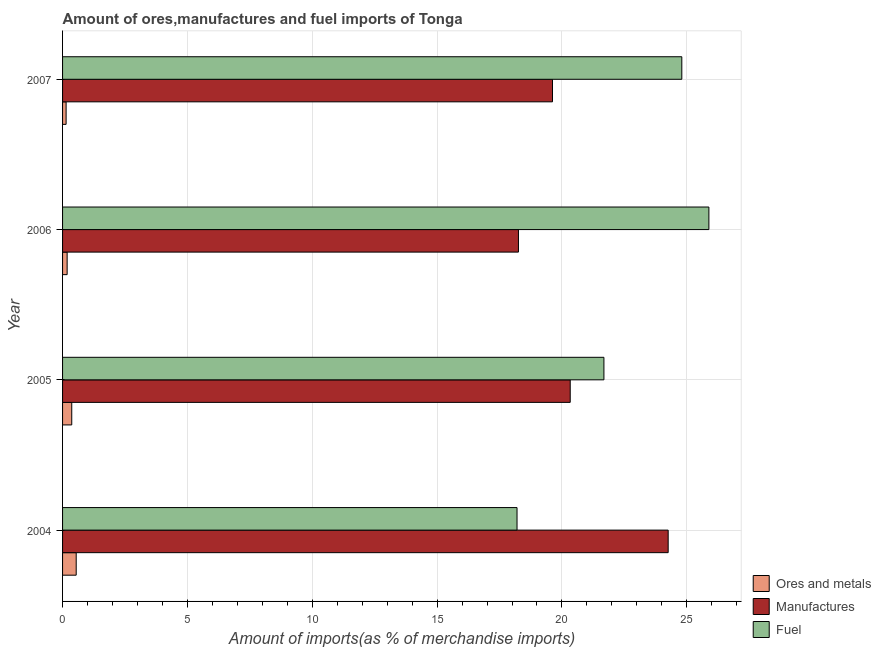How many different coloured bars are there?
Your answer should be compact. 3. Are the number of bars on each tick of the Y-axis equal?
Provide a short and direct response. Yes. What is the label of the 2nd group of bars from the top?
Make the answer very short. 2006. What is the percentage of manufactures imports in 2005?
Offer a terse response. 20.33. Across all years, what is the maximum percentage of manufactures imports?
Keep it short and to the point. 24.25. Across all years, what is the minimum percentage of ores and metals imports?
Make the answer very short. 0.14. In which year was the percentage of manufactures imports minimum?
Offer a very short reply. 2006. What is the total percentage of ores and metals imports in the graph?
Ensure brevity in your answer.  1.24. What is the difference between the percentage of manufactures imports in 2004 and that in 2005?
Give a very brief answer. 3.92. What is the difference between the percentage of manufactures imports in 2006 and the percentage of ores and metals imports in 2007?
Offer a terse response. 18.12. What is the average percentage of ores and metals imports per year?
Ensure brevity in your answer.  0.31. In the year 2006, what is the difference between the percentage of manufactures imports and percentage of ores and metals imports?
Provide a succinct answer. 18.07. In how many years, is the percentage of fuel imports greater than 19 %?
Make the answer very short. 3. What is the ratio of the percentage of manufactures imports in 2004 to that in 2007?
Ensure brevity in your answer.  1.24. What is the difference between the highest and the second highest percentage of manufactures imports?
Give a very brief answer. 3.92. What is the difference between the highest and the lowest percentage of ores and metals imports?
Give a very brief answer. 0.4. What does the 1st bar from the top in 2007 represents?
Your answer should be very brief. Fuel. What does the 3rd bar from the bottom in 2004 represents?
Make the answer very short. Fuel. Is it the case that in every year, the sum of the percentage of ores and metals imports and percentage of manufactures imports is greater than the percentage of fuel imports?
Provide a short and direct response. No. How many bars are there?
Make the answer very short. 12. Are all the bars in the graph horizontal?
Provide a succinct answer. Yes. Does the graph contain any zero values?
Offer a terse response. No. Does the graph contain grids?
Give a very brief answer. Yes. Where does the legend appear in the graph?
Offer a terse response. Bottom right. How are the legend labels stacked?
Your response must be concise. Vertical. What is the title of the graph?
Keep it short and to the point. Amount of ores,manufactures and fuel imports of Tonga. Does "Industry" appear as one of the legend labels in the graph?
Your response must be concise. No. What is the label or title of the X-axis?
Give a very brief answer. Amount of imports(as % of merchandise imports). What is the label or title of the Y-axis?
Provide a succinct answer. Year. What is the Amount of imports(as % of merchandise imports) in Ores and metals in 2004?
Your answer should be compact. 0.55. What is the Amount of imports(as % of merchandise imports) in Manufactures in 2004?
Your answer should be compact. 24.25. What is the Amount of imports(as % of merchandise imports) in Fuel in 2004?
Make the answer very short. 18.2. What is the Amount of imports(as % of merchandise imports) in Ores and metals in 2005?
Your response must be concise. 0.37. What is the Amount of imports(as % of merchandise imports) in Manufactures in 2005?
Keep it short and to the point. 20.33. What is the Amount of imports(as % of merchandise imports) of Fuel in 2005?
Provide a short and direct response. 21.68. What is the Amount of imports(as % of merchandise imports) in Ores and metals in 2006?
Ensure brevity in your answer.  0.18. What is the Amount of imports(as % of merchandise imports) in Manufactures in 2006?
Provide a short and direct response. 18.26. What is the Amount of imports(as % of merchandise imports) of Fuel in 2006?
Your answer should be compact. 25.88. What is the Amount of imports(as % of merchandise imports) of Ores and metals in 2007?
Provide a succinct answer. 0.14. What is the Amount of imports(as % of merchandise imports) of Manufactures in 2007?
Provide a short and direct response. 19.62. What is the Amount of imports(as % of merchandise imports) of Fuel in 2007?
Offer a terse response. 24.8. Across all years, what is the maximum Amount of imports(as % of merchandise imports) of Ores and metals?
Your answer should be compact. 0.55. Across all years, what is the maximum Amount of imports(as % of merchandise imports) in Manufactures?
Ensure brevity in your answer.  24.25. Across all years, what is the maximum Amount of imports(as % of merchandise imports) of Fuel?
Offer a terse response. 25.88. Across all years, what is the minimum Amount of imports(as % of merchandise imports) of Ores and metals?
Offer a very short reply. 0.14. Across all years, what is the minimum Amount of imports(as % of merchandise imports) in Manufactures?
Give a very brief answer. 18.26. Across all years, what is the minimum Amount of imports(as % of merchandise imports) in Fuel?
Provide a short and direct response. 18.2. What is the total Amount of imports(as % of merchandise imports) in Ores and metals in the graph?
Make the answer very short. 1.24. What is the total Amount of imports(as % of merchandise imports) in Manufactures in the graph?
Your answer should be very brief. 82.46. What is the total Amount of imports(as % of merchandise imports) of Fuel in the graph?
Make the answer very short. 90.56. What is the difference between the Amount of imports(as % of merchandise imports) in Ores and metals in 2004 and that in 2005?
Make the answer very short. 0.18. What is the difference between the Amount of imports(as % of merchandise imports) in Manufactures in 2004 and that in 2005?
Your answer should be compact. 3.92. What is the difference between the Amount of imports(as % of merchandise imports) in Fuel in 2004 and that in 2005?
Ensure brevity in your answer.  -3.48. What is the difference between the Amount of imports(as % of merchandise imports) in Ores and metals in 2004 and that in 2006?
Make the answer very short. 0.36. What is the difference between the Amount of imports(as % of merchandise imports) in Manufactures in 2004 and that in 2006?
Give a very brief answer. 6. What is the difference between the Amount of imports(as % of merchandise imports) in Fuel in 2004 and that in 2006?
Provide a short and direct response. -7.68. What is the difference between the Amount of imports(as % of merchandise imports) in Ores and metals in 2004 and that in 2007?
Offer a very short reply. 0.4. What is the difference between the Amount of imports(as % of merchandise imports) in Manufactures in 2004 and that in 2007?
Your response must be concise. 4.63. What is the difference between the Amount of imports(as % of merchandise imports) of Fuel in 2004 and that in 2007?
Provide a succinct answer. -6.6. What is the difference between the Amount of imports(as % of merchandise imports) in Ores and metals in 2005 and that in 2006?
Keep it short and to the point. 0.18. What is the difference between the Amount of imports(as % of merchandise imports) in Manufactures in 2005 and that in 2006?
Your response must be concise. 2.07. What is the difference between the Amount of imports(as % of merchandise imports) in Fuel in 2005 and that in 2006?
Offer a terse response. -4.2. What is the difference between the Amount of imports(as % of merchandise imports) in Ores and metals in 2005 and that in 2007?
Your answer should be compact. 0.23. What is the difference between the Amount of imports(as % of merchandise imports) of Manufactures in 2005 and that in 2007?
Offer a terse response. 0.71. What is the difference between the Amount of imports(as % of merchandise imports) in Fuel in 2005 and that in 2007?
Keep it short and to the point. -3.12. What is the difference between the Amount of imports(as % of merchandise imports) of Ores and metals in 2006 and that in 2007?
Offer a terse response. 0.04. What is the difference between the Amount of imports(as % of merchandise imports) of Manufactures in 2006 and that in 2007?
Make the answer very short. -1.36. What is the difference between the Amount of imports(as % of merchandise imports) of Fuel in 2006 and that in 2007?
Offer a very short reply. 1.08. What is the difference between the Amount of imports(as % of merchandise imports) of Ores and metals in 2004 and the Amount of imports(as % of merchandise imports) of Manufactures in 2005?
Give a very brief answer. -19.78. What is the difference between the Amount of imports(as % of merchandise imports) of Ores and metals in 2004 and the Amount of imports(as % of merchandise imports) of Fuel in 2005?
Offer a terse response. -21.13. What is the difference between the Amount of imports(as % of merchandise imports) of Manufactures in 2004 and the Amount of imports(as % of merchandise imports) of Fuel in 2005?
Keep it short and to the point. 2.57. What is the difference between the Amount of imports(as % of merchandise imports) of Ores and metals in 2004 and the Amount of imports(as % of merchandise imports) of Manufactures in 2006?
Offer a very short reply. -17.71. What is the difference between the Amount of imports(as % of merchandise imports) of Ores and metals in 2004 and the Amount of imports(as % of merchandise imports) of Fuel in 2006?
Offer a very short reply. -25.34. What is the difference between the Amount of imports(as % of merchandise imports) in Manufactures in 2004 and the Amount of imports(as % of merchandise imports) in Fuel in 2006?
Offer a terse response. -1.63. What is the difference between the Amount of imports(as % of merchandise imports) of Ores and metals in 2004 and the Amount of imports(as % of merchandise imports) of Manufactures in 2007?
Your answer should be very brief. -19.08. What is the difference between the Amount of imports(as % of merchandise imports) of Ores and metals in 2004 and the Amount of imports(as % of merchandise imports) of Fuel in 2007?
Give a very brief answer. -24.25. What is the difference between the Amount of imports(as % of merchandise imports) in Manufactures in 2004 and the Amount of imports(as % of merchandise imports) in Fuel in 2007?
Your answer should be compact. -0.55. What is the difference between the Amount of imports(as % of merchandise imports) in Ores and metals in 2005 and the Amount of imports(as % of merchandise imports) in Manufactures in 2006?
Your response must be concise. -17.89. What is the difference between the Amount of imports(as % of merchandise imports) of Ores and metals in 2005 and the Amount of imports(as % of merchandise imports) of Fuel in 2006?
Your answer should be very brief. -25.52. What is the difference between the Amount of imports(as % of merchandise imports) of Manufactures in 2005 and the Amount of imports(as % of merchandise imports) of Fuel in 2006?
Provide a short and direct response. -5.55. What is the difference between the Amount of imports(as % of merchandise imports) of Ores and metals in 2005 and the Amount of imports(as % of merchandise imports) of Manufactures in 2007?
Your answer should be compact. -19.25. What is the difference between the Amount of imports(as % of merchandise imports) in Ores and metals in 2005 and the Amount of imports(as % of merchandise imports) in Fuel in 2007?
Your answer should be compact. -24.43. What is the difference between the Amount of imports(as % of merchandise imports) of Manufactures in 2005 and the Amount of imports(as % of merchandise imports) of Fuel in 2007?
Make the answer very short. -4.47. What is the difference between the Amount of imports(as % of merchandise imports) in Ores and metals in 2006 and the Amount of imports(as % of merchandise imports) in Manufactures in 2007?
Give a very brief answer. -19.44. What is the difference between the Amount of imports(as % of merchandise imports) in Ores and metals in 2006 and the Amount of imports(as % of merchandise imports) in Fuel in 2007?
Offer a terse response. -24.62. What is the difference between the Amount of imports(as % of merchandise imports) in Manufactures in 2006 and the Amount of imports(as % of merchandise imports) in Fuel in 2007?
Ensure brevity in your answer.  -6.54. What is the average Amount of imports(as % of merchandise imports) of Ores and metals per year?
Keep it short and to the point. 0.31. What is the average Amount of imports(as % of merchandise imports) of Manufactures per year?
Keep it short and to the point. 20.62. What is the average Amount of imports(as % of merchandise imports) of Fuel per year?
Offer a very short reply. 22.64. In the year 2004, what is the difference between the Amount of imports(as % of merchandise imports) of Ores and metals and Amount of imports(as % of merchandise imports) of Manufactures?
Ensure brevity in your answer.  -23.71. In the year 2004, what is the difference between the Amount of imports(as % of merchandise imports) of Ores and metals and Amount of imports(as % of merchandise imports) of Fuel?
Give a very brief answer. -17.65. In the year 2004, what is the difference between the Amount of imports(as % of merchandise imports) of Manufactures and Amount of imports(as % of merchandise imports) of Fuel?
Keep it short and to the point. 6.05. In the year 2005, what is the difference between the Amount of imports(as % of merchandise imports) in Ores and metals and Amount of imports(as % of merchandise imports) in Manufactures?
Provide a short and direct response. -19.96. In the year 2005, what is the difference between the Amount of imports(as % of merchandise imports) of Ores and metals and Amount of imports(as % of merchandise imports) of Fuel?
Your answer should be compact. -21.31. In the year 2005, what is the difference between the Amount of imports(as % of merchandise imports) in Manufactures and Amount of imports(as % of merchandise imports) in Fuel?
Ensure brevity in your answer.  -1.35. In the year 2006, what is the difference between the Amount of imports(as % of merchandise imports) in Ores and metals and Amount of imports(as % of merchandise imports) in Manufactures?
Provide a short and direct response. -18.07. In the year 2006, what is the difference between the Amount of imports(as % of merchandise imports) in Ores and metals and Amount of imports(as % of merchandise imports) in Fuel?
Offer a terse response. -25.7. In the year 2006, what is the difference between the Amount of imports(as % of merchandise imports) in Manufactures and Amount of imports(as % of merchandise imports) in Fuel?
Ensure brevity in your answer.  -7.63. In the year 2007, what is the difference between the Amount of imports(as % of merchandise imports) in Ores and metals and Amount of imports(as % of merchandise imports) in Manufactures?
Your answer should be very brief. -19.48. In the year 2007, what is the difference between the Amount of imports(as % of merchandise imports) of Ores and metals and Amount of imports(as % of merchandise imports) of Fuel?
Offer a very short reply. -24.66. In the year 2007, what is the difference between the Amount of imports(as % of merchandise imports) of Manufactures and Amount of imports(as % of merchandise imports) of Fuel?
Offer a terse response. -5.18. What is the ratio of the Amount of imports(as % of merchandise imports) of Ores and metals in 2004 to that in 2005?
Make the answer very short. 1.48. What is the ratio of the Amount of imports(as % of merchandise imports) of Manufactures in 2004 to that in 2005?
Give a very brief answer. 1.19. What is the ratio of the Amount of imports(as % of merchandise imports) in Fuel in 2004 to that in 2005?
Your response must be concise. 0.84. What is the ratio of the Amount of imports(as % of merchandise imports) of Ores and metals in 2004 to that in 2006?
Your answer should be compact. 2.98. What is the ratio of the Amount of imports(as % of merchandise imports) of Manufactures in 2004 to that in 2006?
Your response must be concise. 1.33. What is the ratio of the Amount of imports(as % of merchandise imports) of Fuel in 2004 to that in 2006?
Offer a very short reply. 0.7. What is the ratio of the Amount of imports(as % of merchandise imports) in Ores and metals in 2004 to that in 2007?
Your response must be concise. 3.85. What is the ratio of the Amount of imports(as % of merchandise imports) in Manufactures in 2004 to that in 2007?
Provide a succinct answer. 1.24. What is the ratio of the Amount of imports(as % of merchandise imports) in Fuel in 2004 to that in 2007?
Ensure brevity in your answer.  0.73. What is the ratio of the Amount of imports(as % of merchandise imports) in Ores and metals in 2005 to that in 2006?
Offer a very short reply. 2.01. What is the ratio of the Amount of imports(as % of merchandise imports) in Manufactures in 2005 to that in 2006?
Offer a terse response. 1.11. What is the ratio of the Amount of imports(as % of merchandise imports) in Fuel in 2005 to that in 2006?
Make the answer very short. 0.84. What is the ratio of the Amount of imports(as % of merchandise imports) in Ores and metals in 2005 to that in 2007?
Keep it short and to the point. 2.59. What is the ratio of the Amount of imports(as % of merchandise imports) of Manufactures in 2005 to that in 2007?
Offer a terse response. 1.04. What is the ratio of the Amount of imports(as % of merchandise imports) of Fuel in 2005 to that in 2007?
Make the answer very short. 0.87. What is the ratio of the Amount of imports(as % of merchandise imports) in Ores and metals in 2006 to that in 2007?
Make the answer very short. 1.29. What is the ratio of the Amount of imports(as % of merchandise imports) of Manufactures in 2006 to that in 2007?
Make the answer very short. 0.93. What is the ratio of the Amount of imports(as % of merchandise imports) of Fuel in 2006 to that in 2007?
Make the answer very short. 1.04. What is the difference between the highest and the second highest Amount of imports(as % of merchandise imports) of Ores and metals?
Offer a very short reply. 0.18. What is the difference between the highest and the second highest Amount of imports(as % of merchandise imports) of Manufactures?
Offer a terse response. 3.92. What is the difference between the highest and the second highest Amount of imports(as % of merchandise imports) in Fuel?
Make the answer very short. 1.08. What is the difference between the highest and the lowest Amount of imports(as % of merchandise imports) of Ores and metals?
Your answer should be very brief. 0.4. What is the difference between the highest and the lowest Amount of imports(as % of merchandise imports) in Manufactures?
Your answer should be very brief. 6. What is the difference between the highest and the lowest Amount of imports(as % of merchandise imports) in Fuel?
Provide a succinct answer. 7.68. 